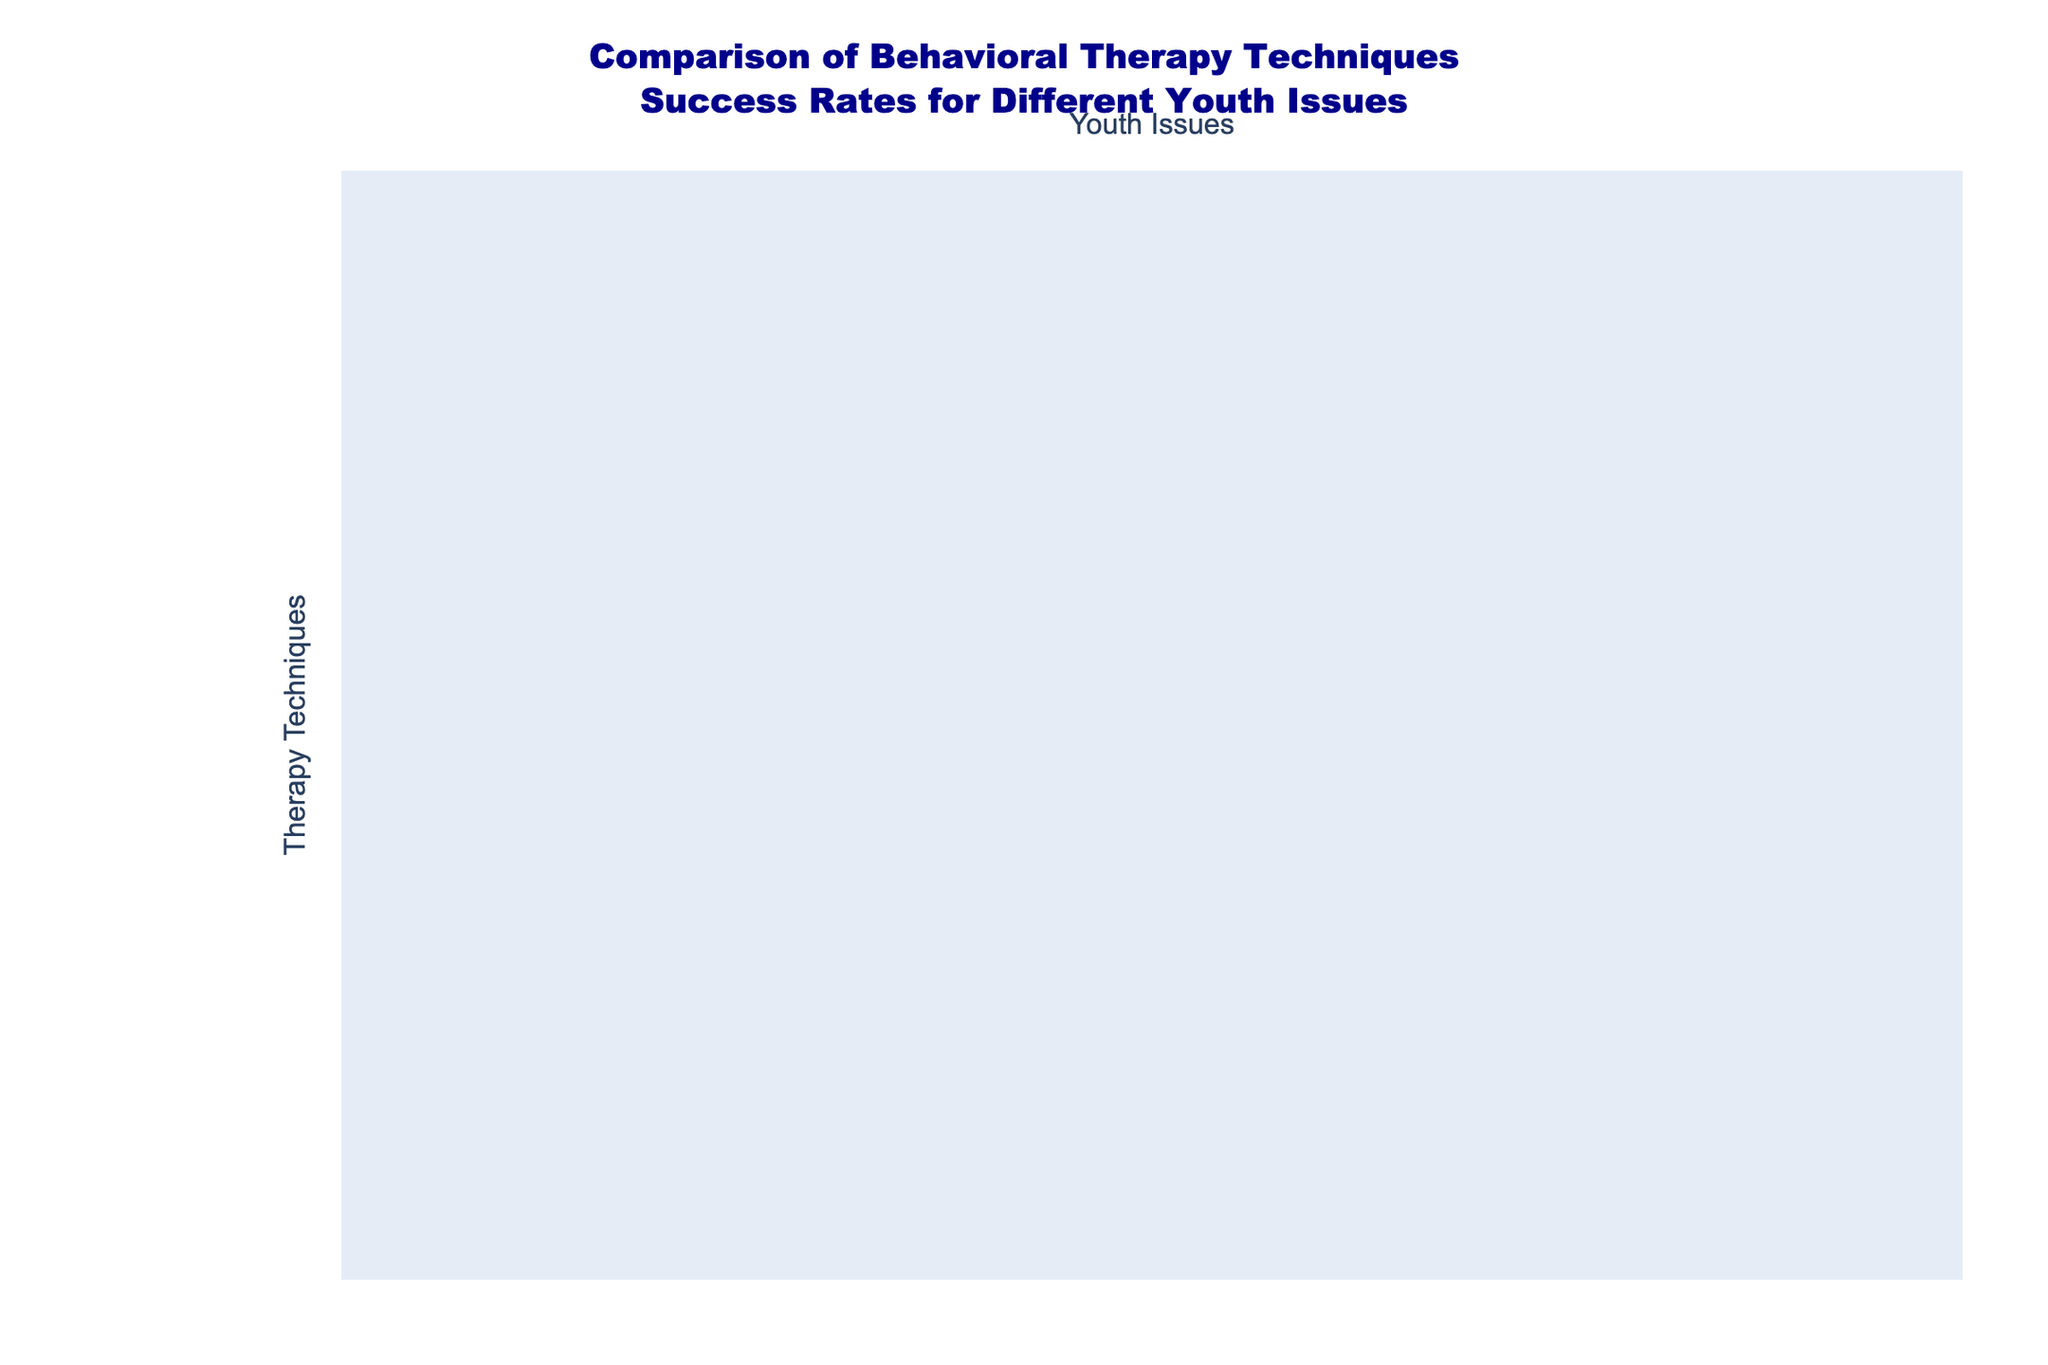What is the success rate of Cognitive Behavioral Therapy for treating Anxiety? According to the table, the success rate of Cognitive Behavioral Therapy for Anxiety is listed as 80%.
Answer: 80% Which therapy technique has the highest success rate for Conduct Disorder? By examining the table, Family-Based Therapy has the highest success rate for Conduct Disorder at 70%.
Answer: 70% What is the average success rate of Dialectical Behavior Therapy across all youth issues? The success rates for Dialectical Behavior Therapy are 70% (Depression), 75% (Anxiety), 55% (ADHD), 65% (Substance Abuse), and 55% (Conduct Disorder). Adding these values gives 70 + 75 + 55 + 65 + 55 = 320. Dividing by 5 gives an average of 320 / 5 = 64%.
Answer: 64% Is Acceptance and Commitment Therapy effective for treating ADHD? Looking at the table, the success rate for Acceptance and Commitment Therapy in treating ADHD is 50%, indicating it may be less effective for this issue.
Answer: No Which therapy technique shows the most balanced success rates across all youth issues? To determine balance, we look for a technique where the success rates do not vary greatly. Group Therapy has rates of 65%, 70%, 60%, 70%, and 65%, which are relatively close to each other compared to the others. It shows less variation.
Answer: Group Therapy What is the difference in success rates between Motivational Interviewing for Substance Abuse and Play Therapy for the same issue? From the table, Motivational Interviewing for Substance Abuse has a success rate of 75%, while Play Therapy has a rate of 40%. The difference is 75% - 40% = 35%.
Answer: 35% Which therapy technique is least effective for treating ADHD? By inspecting the table, Acceptance and Commitment Therapy shows the lowest success rate for ADHD at 50%.
Answer: Acceptance and Commitment Therapy What is the range of success rates for Family-Based Therapy across the different youth issues? The success rates for Family-Based Therapy are 65% (Depression), 60% (Anxiety), 70% (ADHD), 65% (Substance Abuse), and 70% (Conduct Disorder). The highest rate is 70% and the lowest is 60%, leading to a range of 70% - 60% = 10%.
Answer: 10% Does Mindfulness-Based Cognitive Therapy have a higher success rate for treating Anxiety or Conduct Disorder? From the table, Mindfulness-Based Cognitive Therapy has a success rate of 75% for Anxiety and 50% for Conduct Disorder. Thus, it is higher for Anxiety.
Answer: Yes Identify the therapy technique with the lowest overall success rate across all youth issues. To identify it, we can consider the lowest figures for each therapy. For example, Art Therapy has the lowest rates of 50% (Conduct Disorder) and 45% (Substance Abuse), making it the least effective overall based on the lower score metrics.
Answer: Art Therapy 